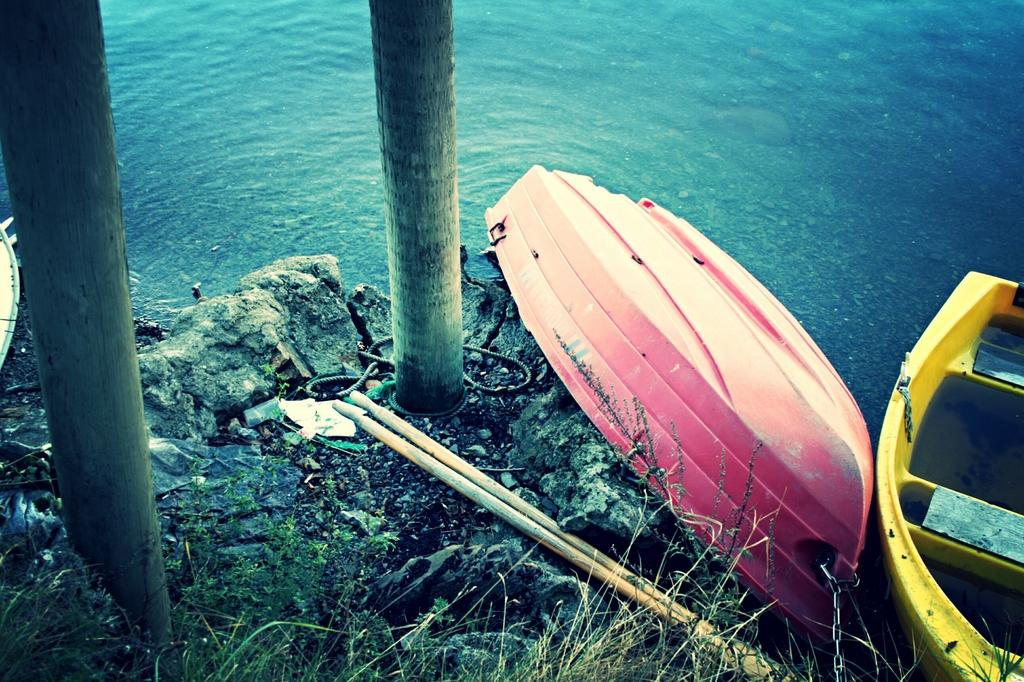What type of vehicles can be seen in the image? There are boats in the image. What structures are present in the image? There are poles in the image. What natural elements can be seen in the image? There are rocks and plants in the image. What is the primary substance visible in the image? There is water visible in the image. What type of hat is the base of the suggestion in the image? There is no hat, base, or suggestion present in the image. 